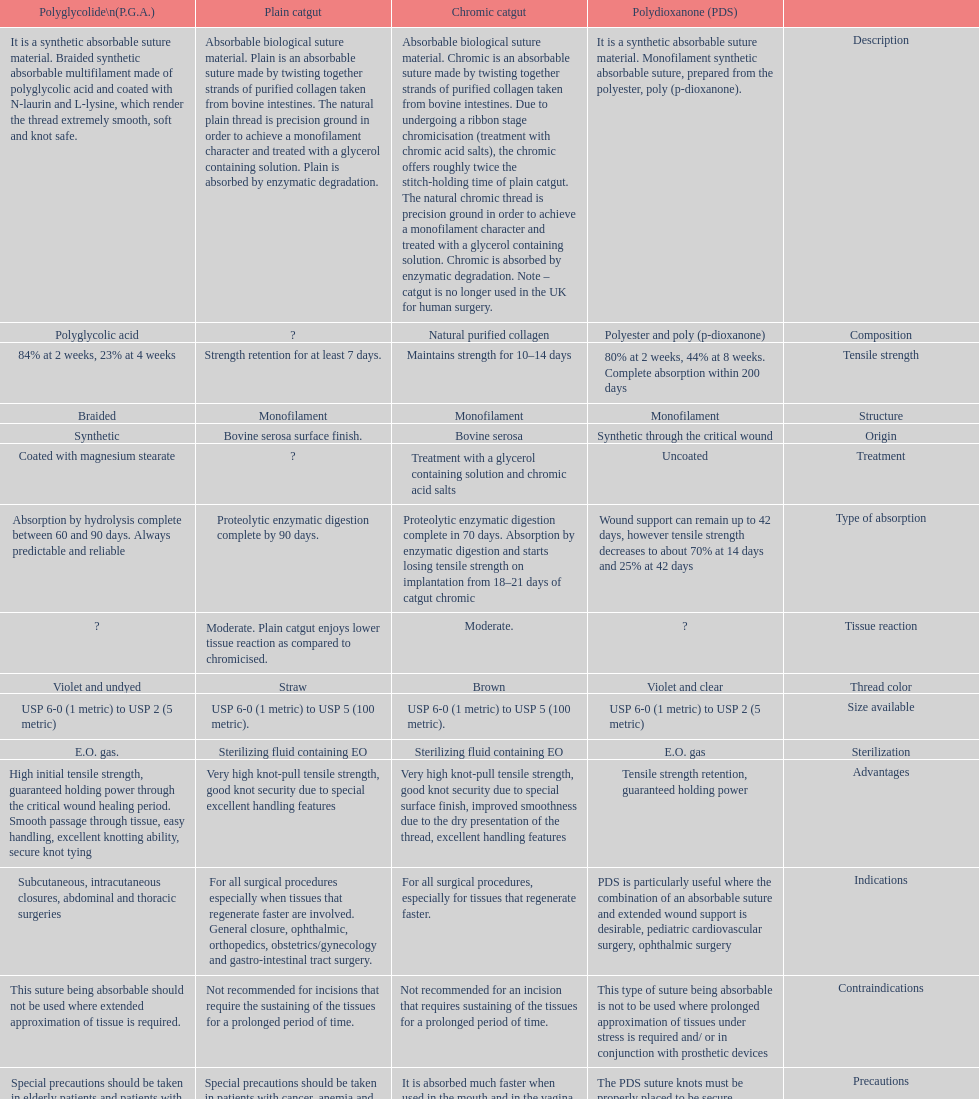What type of suture is not to be used in conjunction with prosthetic devices? Polydioxanone (PDS). 